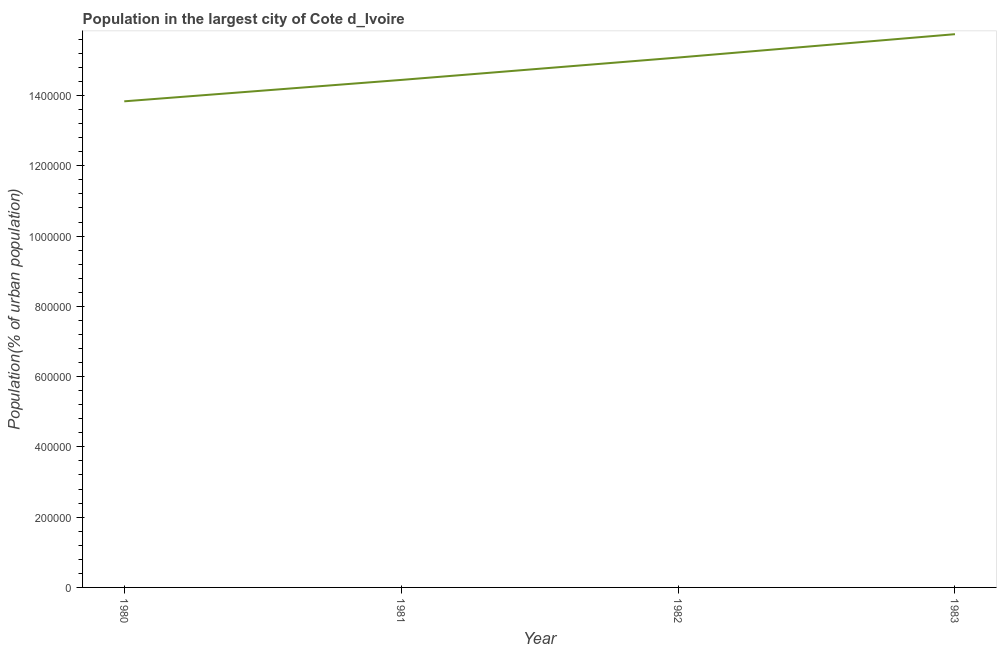What is the population in largest city in 1983?
Your response must be concise. 1.57e+06. Across all years, what is the maximum population in largest city?
Your answer should be compact. 1.57e+06. Across all years, what is the minimum population in largest city?
Your answer should be compact. 1.38e+06. In which year was the population in largest city maximum?
Offer a very short reply. 1983. In which year was the population in largest city minimum?
Your answer should be very brief. 1980. What is the sum of the population in largest city?
Make the answer very short. 5.91e+06. What is the difference between the population in largest city in 1982 and 1983?
Offer a very short reply. -6.65e+04. What is the average population in largest city per year?
Your answer should be very brief. 1.48e+06. What is the median population in largest city?
Give a very brief answer. 1.48e+06. Do a majority of the years between 1982 and 1981 (inclusive) have population in largest city greater than 200000 %?
Your answer should be very brief. No. What is the ratio of the population in largest city in 1981 to that in 1983?
Provide a succinct answer. 0.92. What is the difference between the highest and the second highest population in largest city?
Provide a succinct answer. 6.65e+04. What is the difference between the highest and the lowest population in largest city?
Ensure brevity in your answer.  1.91e+05. In how many years, is the population in largest city greater than the average population in largest city taken over all years?
Your answer should be very brief. 2. How many lines are there?
Offer a very short reply. 1. How many years are there in the graph?
Your answer should be compact. 4. Does the graph contain grids?
Your answer should be compact. No. What is the title of the graph?
Provide a succinct answer. Population in the largest city of Cote d_Ivoire. What is the label or title of the Y-axis?
Ensure brevity in your answer.  Population(% of urban population). What is the Population(% of urban population) in 1980?
Your answer should be very brief. 1.38e+06. What is the Population(% of urban population) in 1981?
Provide a short and direct response. 1.44e+06. What is the Population(% of urban population) of 1982?
Keep it short and to the point. 1.51e+06. What is the Population(% of urban population) of 1983?
Your response must be concise. 1.57e+06. What is the difference between the Population(% of urban population) in 1980 and 1981?
Offer a very short reply. -6.09e+04. What is the difference between the Population(% of urban population) in 1980 and 1982?
Keep it short and to the point. -1.25e+05. What is the difference between the Population(% of urban population) in 1980 and 1983?
Keep it short and to the point. -1.91e+05. What is the difference between the Population(% of urban population) in 1981 and 1982?
Offer a very short reply. -6.37e+04. What is the difference between the Population(% of urban population) in 1981 and 1983?
Ensure brevity in your answer.  -1.30e+05. What is the difference between the Population(% of urban population) in 1982 and 1983?
Offer a terse response. -6.65e+04. What is the ratio of the Population(% of urban population) in 1980 to that in 1981?
Provide a short and direct response. 0.96. What is the ratio of the Population(% of urban population) in 1980 to that in 1982?
Keep it short and to the point. 0.92. What is the ratio of the Population(% of urban population) in 1980 to that in 1983?
Provide a succinct answer. 0.88. What is the ratio of the Population(% of urban population) in 1981 to that in 1982?
Make the answer very short. 0.96. What is the ratio of the Population(% of urban population) in 1981 to that in 1983?
Your answer should be very brief. 0.92. What is the ratio of the Population(% of urban population) in 1982 to that in 1983?
Keep it short and to the point. 0.96. 